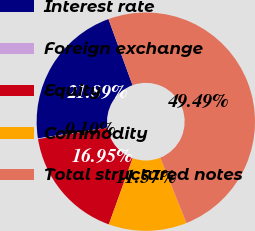Convert chart to OTSL. <chart><loc_0><loc_0><loc_500><loc_500><pie_chart><fcel>Interest rate<fcel>Foreign exchange<fcel>Equity<fcel>Commodity<fcel>Total structured notes<nl><fcel>21.89%<fcel>0.1%<fcel>16.95%<fcel>11.57%<fcel>49.49%<nl></chart> 